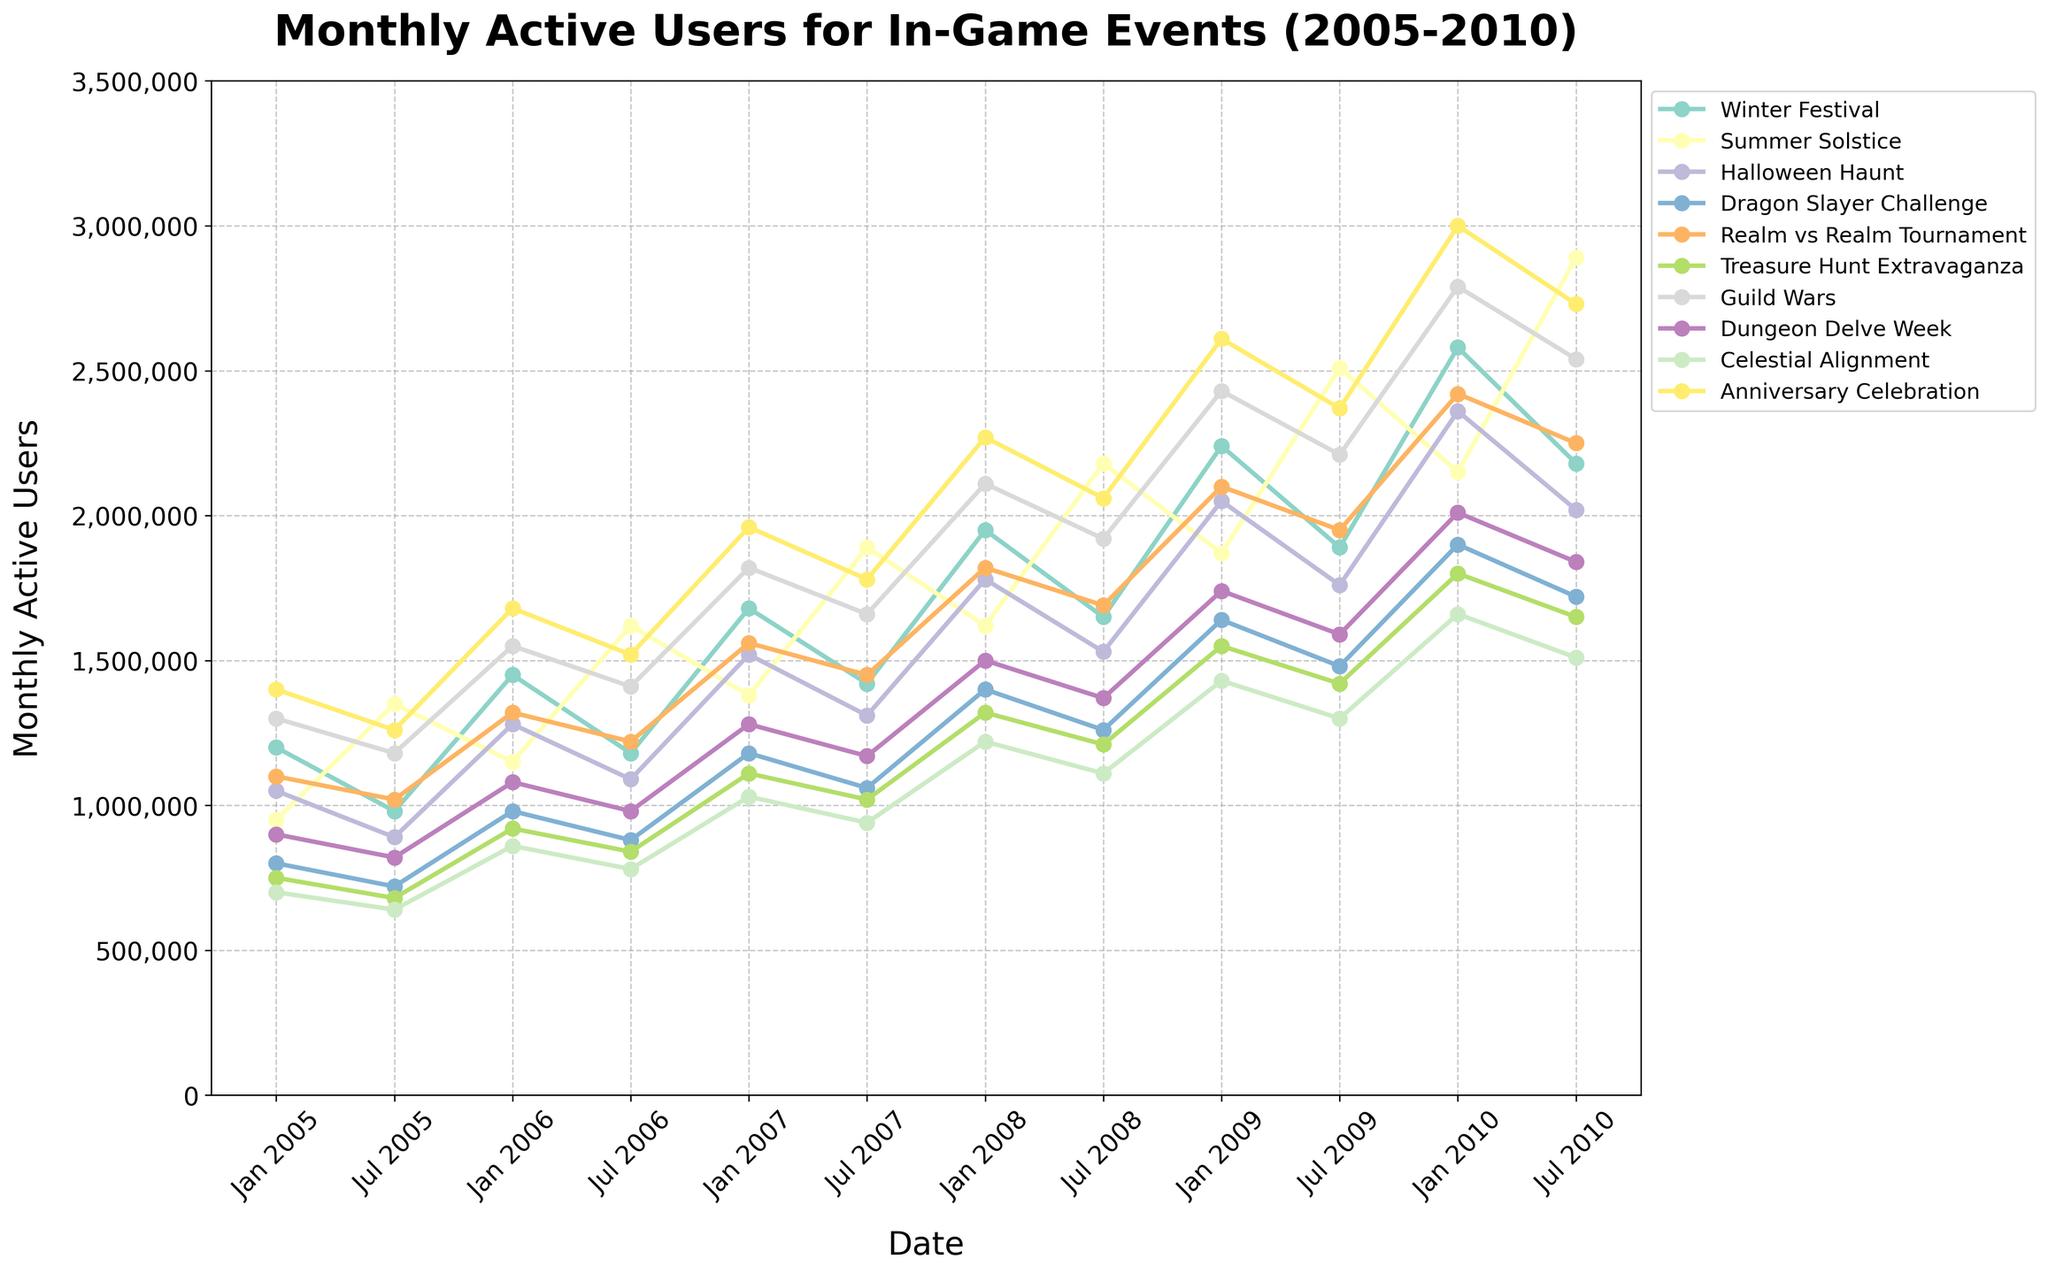During the 2005 to 2010 period, which event consistently had the highest number of monthly active users in January? To find the event with the highest number of monthly active users in January from 2005 to 2010, we need to observe the data points for each event in the figure for January of each year. "Anniversary Celebration" consistently has the highest numbers: Jan 2005 (1,400,000), Jan 2006 (1,680,000), Jan 2007 (1,960,000), Jan 2008 (2,270,000), Jan 2009 (2,610,000), and Jan 2010 (3,000,000). Therefore, "Anniversary Celebration" consistently had the highest number of monthly users in January.
Answer: Anniversary Celebration Which event showed the most significant overall increase in monthly active users from Jan 2005 to July 2010? Calculate the difference in the number of users for each event from Jan 2005 to July 2010. The differences are: Winter Festival (980,000), Summer Solstice (1,940,000), Halloween Haunt (970,000), Dragon Slayer Challenge (920,000), Realm vs Realm Tournament (1,320,000), Treasure Hunt Extravaganza (1,050,000), Guild Wars (1,240,000), Dungeon Delve Week (940,000), Celestial Alignment (910,000), and Anniversary Celebration (1,600,000). The "Summer Solstice" event shows the most significant increase.
Answer: Summer Solstice Between "Winter Festival" and "Halloween Haunt," which event had a larger number of monthly active users in July 2008? Compare the number of monthly active users for July 2008 for both events. "Winter Festival" had 1,650,000 users and "Halloween Haunt" had 1,530,000. Therefore, "Winter Festival" had a larger number.
Answer: Winter Festival What is the average number of monthly active users for the "Dragon Slayer Challenge" in July (from 2005 to 2010)? To find the average, first sum the number of monthly active users for the "Dragon Slayer Challenge" in July from 2005 to 2010: 720,000 + 880,000 + 1,060,000 + 1,260,000 + 1,480,000 + 1,720,000 = 7,120,000. Then, divide by the number of data points (6). 7,120,000 / 6 = 1,186,667.
Answer: 1,186,667 In which year did the "Guild Wars" event first surpass 2,000,000 monthly active users? Observe the trend line for the "Guild Wars" event and find the first instance where the number of users exceeds 2,000,000. This occurred in January 2009 with 2,430,000 users. Therefore, the first year is 2009.
Answer: 2009 Which event has the steepest increase in monthly active users from Jan 2008 to Jan 2009? To determine the event with the steepest increase, we look at the change for each event between these two points. The changes are: Winter Festival (290,000), Summer Solstice (250,000), Halloween Haunt (270,000), Dragon Slayer Challenge (240,000), Realm vs Realm Tournament (280,000), Treasure Hunt Extravaganza (230,000), Guild Wars (320,000), Dungeon Delve Week (240,000), Celestial Alignment (260,000), and Anniversary Celebration (340,000). The event with the steepest increase is the "Anniversary Celebration" with an increase of 340,000 users.
Answer: Anniversary Celebration What is the total number of monthly active users for all events in July 2010? Add the number of monthly active users for each event in July 2010: Winter Festival (2,180,000), Summer Solstice (2,890,000), Halloween Haunt (2,020,000), Dragon Slayer Challenge (1,720,000), Realm vs Realm Tournament (2,250,000), Treasure Hunt Extravaganza (1,650,000), Guild Wars (2,540,000), Dungeon Delve Week (1,840,000), Celestial Alignment (1,510,000), and Anniversary Celebration (2,730,000). Total = 21,330,000.
Answer: 21,330,000 